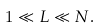<formula> <loc_0><loc_0><loc_500><loc_500>1 \ll L \ll N .</formula> 